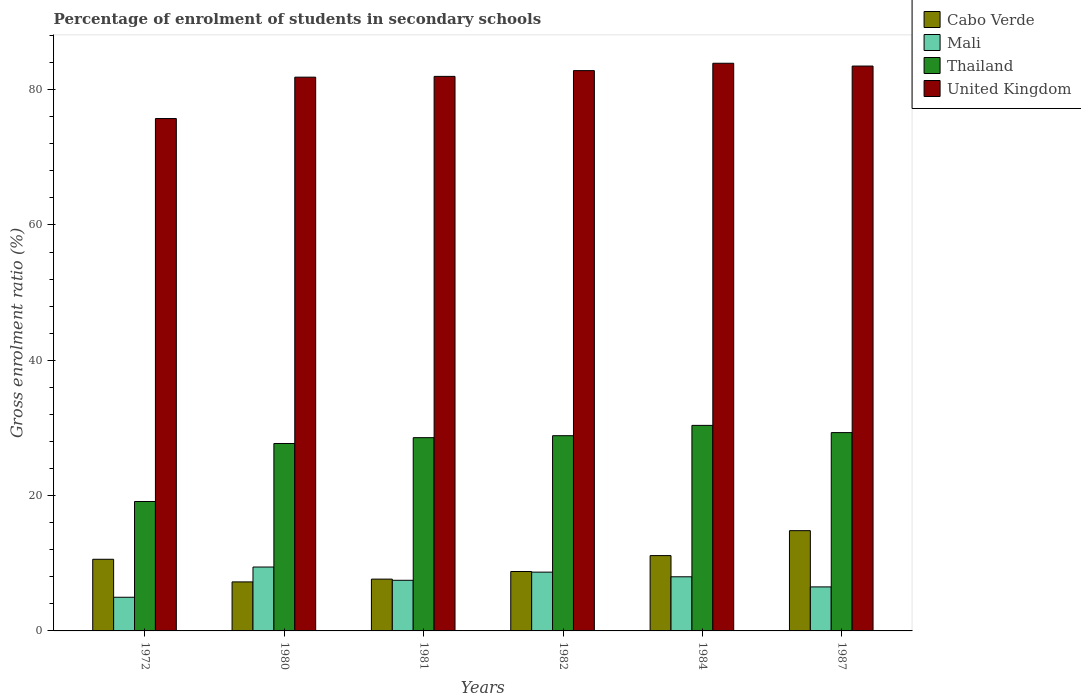Are the number of bars on each tick of the X-axis equal?
Provide a succinct answer. Yes. How many bars are there on the 3rd tick from the left?
Provide a short and direct response. 4. In how many cases, is the number of bars for a given year not equal to the number of legend labels?
Make the answer very short. 0. What is the percentage of students enrolled in secondary schools in Cabo Verde in 1987?
Ensure brevity in your answer.  14.82. Across all years, what is the maximum percentage of students enrolled in secondary schools in Thailand?
Ensure brevity in your answer.  30.38. Across all years, what is the minimum percentage of students enrolled in secondary schools in United Kingdom?
Your response must be concise. 75.72. In which year was the percentage of students enrolled in secondary schools in Cabo Verde maximum?
Ensure brevity in your answer.  1987. In which year was the percentage of students enrolled in secondary schools in Thailand minimum?
Make the answer very short. 1972. What is the total percentage of students enrolled in secondary schools in United Kingdom in the graph?
Your response must be concise. 489.71. What is the difference between the percentage of students enrolled in secondary schools in Mali in 1980 and that in 1981?
Ensure brevity in your answer.  1.96. What is the difference between the percentage of students enrolled in secondary schools in Thailand in 1987 and the percentage of students enrolled in secondary schools in Cabo Verde in 1980?
Provide a succinct answer. 22.07. What is the average percentage of students enrolled in secondary schools in Mali per year?
Give a very brief answer. 7.52. In the year 1972, what is the difference between the percentage of students enrolled in secondary schools in Cabo Verde and percentage of students enrolled in secondary schools in Thailand?
Provide a short and direct response. -8.54. In how many years, is the percentage of students enrolled in secondary schools in Thailand greater than 44 %?
Provide a short and direct response. 0. What is the ratio of the percentage of students enrolled in secondary schools in Thailand in 1980 to that in 1984?
Keep it short and to the point. 0.91. Is the difference between the percentage of students enrolled in secondary schools in Cabo Verde in 1984 and 1987 greater than the difference between the percentage of students enrolled in secondary schools in Thailand in 1984 and 1987?
Provide a short and direct response. No. What is the difference between the highest and the second highest percentage of students enrolled in secondary schools in Cabo Verde?
Offer a very short reply. 3.68. What is the difference between the highest and the lowest percentage of students enrolled in secondary schools in Thailand?
Give a very brief answer. 11.25. Is it the case that in every year, the sum of the percentage of students enrolled in secondary schools in Thailand and percentage of students enrolled in secondary schools in United Kingdom is greater than the sum of percentage of students enrolled in secondary schools in Cabo Verde and percentage of students enrolled in secondary schools in Mali?
Offer a terse response. Yes. What does the 3rd bar from the left in 1984 represents?
Offer a terse response. Thailand. What does the 4th bar from the right in 1982 represents?
Keep it short and to the point. Cabo Verde. What is the difference between two consecutive major ticks on the Y-axis?
Keep it short and to the point. 20. Does the graph contain any zero values?
Keep it short and to the point. No. How many legend labels are there?
Ensure brevity in your answer.  4. What is the title of the graph?
Make the answer very short. Percentage of enrolment of students in secondary schools. What is the label or title of the Y-axis?
Offer a terse response. Gross enrolment ratio (%). What is the Gross enrolment ratio (%) in Cabo Verde in 1972?
Ensure brevity in your answer.  10.59. What is the Gross enrolment ratio (%) in Mali in 1972?
Your response must be concise. 4.97. What is the Gross enrolment ratio (%) in Thailand in 1972?
Your response must be concise. 19.13. What is the Gross enrolment ratio (%) of United Kingdom in 1972?
Make the answer very short. 75.72. What is the Gross enrolment ratio (%) of Cabo Verde in 1980?
Your response must be concise. 7.24. What is the Gross enrolment ratio (%) of Mali in 1980?
Provide a short and direct response. 9.44. What is the Gross enrolment ratio (%) of Thailand in 1980?
Offer a terse response. 27.7. What is the Gross enrolment ratio (%) in United Kingdom in 1980?
Your answer should be very brief. 81.84. What is the Gross enrolment ratio (%) in Cabo Verde in 1981?
Make the answer very short. 7.66. What is the Gross enrolment ratio (%) of Mali in 1981?
Provide a short and direct response. 7.48. What is the Gross enrolment ratio (%) in Thailand in 1981?
Make the answer very short. 28.56. What is the Gross enrolment ratio (%) in United Kingdom in 1981?
Your answer should be very brief. 81.96. What is the Gross enrolment ratio (%) of Cabo Verde in 1982?
Your response must be concise. 8.78. What is the Gross enrolment ratio (%) of Mali in 1982?
Offer a terse response. 8.69. What is the Gross enrolment ratio (%) of Thailand in 1982?
Provide a succinct answer. 28.85. What is the Gross enrolment ratio (%) in United Kingdom in 1982?
Ensure brevity in your answer.  82.81. What is the Gross enrolment ratio (%) in Cabo Verde in 1984?
Give a very brief answer. 11.13. What is the Gross enrolment ratio (%) of Mali in 1984?
Your answer should be compact. 8. What is the Gross enrolment ratio (%) of Thailand in 1984?
Provide a succinct answer. 30.38. What is the Gross enrolment ratio (%) of United Kingdom in 1984?
Your answer should be very brief. 83.9. What is the Gross enrolment ratio (%) in Cabo Verde in 1987?
Your response must be concise. 14.82. What is the Gross enrolment ratio (%) of Mali in 1987?
Ensure brevity in your answer.  6.51. What is the Gross enrolment ratio (%) in Thailand in 1987?
Make the answer very short. 29.31. What is the Gross enrolment ratio (%) of United Kingdom in 1987?
Provide a succinct answer. 83.48. Across all years, what is the maximum Gross enrolment ratio (%) in Cabo Verde?
Your answer should be compact. 14.82. Across all years, what is the maximum Gross enrolment ratio (%) of Mali?
Offer a terse response. 9.44. Across all years, what is the maximum Gross enrolment ratio (%) in Thailand?
Keep it short and to the point. 30.38. Across all years, what is the maximum Gross enrolment ratio (%) in United Kingdom?
Ensure brevity in your answer.  83.9. Across all years, what is the minimum Gross enrolment ratio (%) of Cabo Verde?
Your answer should be compact. 7.24. Across all years, what is the minimum Gross enrolment ratio (%) in Mali?
Your answer should be very brief. 4.97. Across all years, what is the minimum Gross enrolment ratio (%) in Thailand?
Your answer should be compact. 19.13. Across all years, what is the minimum Gross enrolment ratio (%) of United Kingdom?
Offer a very short reply. 75.72. What is the total Gross enrolment ratio (%) in Cabo Verde in the graph?
Your answer should be very brief. 60.22. What is the total Gross enrolment ratio (%) in Mali in the graph?
Your answer should be compact. 45.1. What is the total Gross enrolment ratio (%) of Thailand in the graph?
Provide a short and direct response. 163.93. What is the total Gross enrolment ratio (%) of United Kingdom in the graph?
Offer a very short reply. 489.71. What is the difference between the Gross enrolment ratio (%) in Cabo Verde in 1972 and that in 1980?
Provide a short and direct response. 3.34. What is the difference between the Gross enrolment ratio (%) in Mali in 1972 and that in 1980?
Provide a short and direct response. -4.47. What is the difference between the Gross enrolment ratio (%) in Thailand in 1972 and that in 1980?
Your answer should be very brief. -8.57. What is the difference between the Gross enrolment ratio (%) of United Kingdom in 1972 and that in 1980?
Your answer should be compact. -6.12. What is the difference between the Gross enrolment ratio (%) in Cabo Verde in 1972 and that in 1981?
Provide a short and direct response. 2.93. What is the difference between the Gross enrolment ratio (%) in Mali in 1972 and that in 1981?
Offer a very short reply. -2.51. What is the difference between the Gross enrolment ratio (%) in Thailand in 1972 and that in 1981?
Make the answer very short. -9.43. What is the difference between the Gross enrolment ratio (%) in United Kingdom in 1972 and that in 1981?
Provide a succinct answer. -6.23. What is the difference between the Gross enrolment ratio (%) of Cabo Verde in 1972 and that in 1982?
Your answer should be compact. 1.81. What is the difference between the Gross enrolment ratio (%) in Mali in 1972 and that in 1982?
Your response must be concise. -3.71. What is the difference between the Gross enrolment ratio (%) in Thailand in 1972 and that in 1982?
Provide a short and direct response. -9.72. What is the difference between the Gross enrolment ratio (%) of United Kingdom in 1972 and that in 1982?
Your answer should be very brief. -7.08. What is the difference between the Gross enrolment ratio (%) in Cabo Verde in 1972 and that in 1984?
Ensure brevity in your answer.  -0.54. What is the difference between the Gross enrolment ratio (%) of Mali in 1972 and that in 1984?
Provide a succinct answer. -3.03. What is the difference between the Gross enrolment ratio (%) of Thailand in 1972 and that in 1984?
Offer a terse response. -11.25. What is the difference between the Gross enrolment ratio (%) of United Kingdom in 1972 and that in 1984?
Keep it short and to the point. -8.17. What is the difference between the Gross enrolment ratio (%) of Cabo Verde in 1972 and that in 1987?
Make the answer very short. -4.23. What is the difference between the Gross enrolment ratio (%) of Mali in 1972 and that in 1987?
Offer a terse response. -1.53. What is the difference between the Gross enrolment ratio (%) of Thailand in 1972 and that in 1987?
Offer a very short reply. -10.18. What is the difference between the Gross enrolment ratio (%) of United Kingdom in 1972 and that in 1987?
Make the answer very short. -7.76. What is the difference between the Gross enrolment ratio (%) in Cabo Verde in 1980 and that in 1981?
Your answer should be compact. -0.41. What is the difference between the Gross enrolment ratio (%) in Mali in 1980 and that in 1981?
Offer a terse response. 1.96. What is the difference between the Gross enrolment ratio (%) of Thailand in 1980 and that in 1981?
Give a very brief answer. -0.86. What is the difference between the Gross enrolment ratio (%) in United Kingdom in 1980 and that in 1981?
Give a very brief answer. -0.11. What is the difference between the Gross enrolment ratio (%) in Cabo Verde in 1980 and that in 1982?
Your response must be concise. -1.54. What is the difference between the Gross enrolment ratio (%) in Mali in 1980 and that in 1982?
Keep it short and to the point. 0.75. What is the difference between the Gross enrolment ratio (%) in Thailand in 1980 and that in 1982?
Ensure brevity in your answer.  -1.15. What is the difference between the Gross enrolment ratio (%) of United Kingdom in 1980 and that in 1982?
Ensure brevity in your answer.  -0.97. What is the difference between the Gross enrolment ratio (%) of Cabo Verde in 1980 and that in 1984?
Ensure brevity in your answer.  -3.89. What is the difference between the Gross enrolment ratio (%) of Mali in 1980 and that in 1984?
Offer a terse response. 1.44. What is the difference between the Gross enrolment ratio (%) of Thailand in 1980 and that in 1984?
Provide a short and direct response. -2.68. What is the difference between the Gross enrolment ratio (%) of United Kingdom in 1980 and that in 1984?
Offer a terse response. -2.05. What is the difference between the Gross enrolment ratio (%) of Cabo Verde in 1980 and that in 1987?
Your answer should be compact. -7.57. What is the difference between the Gross enrolment ratio (%) of Mali in 1980 and that in 1987?
Provide a succinct answer. 2.94. What is the difference between the Gross enrolment ratio (%) in Thailand in 1980 and that in 1987?
Ensure brevity in your answer.  -1.61. What is the difference between the Gross enrolment ratio (%) of United Kingdom in 1980 and that in 1987?
Keep it short and to the point. -1.64. What is the difference between the Gross enrolment ratio (%) of Cabo Verde in 1981 and that in 1982?
Give a very brief answer. -1.13. What is the difference between the Gross enrolment ratio (%) of Mali in 1981 and that in 1982?
Give a very brief answer. -1.21. What is the difference between the Gross enrolment ratio (%) in Thailand in 1981 and that in 1982?
Offer a very short reply. -0.29. What is the difference between the Gross enrolment ratio (%) of United Kingdom in 1981 and that in 1982?
Make the answer very short. -0.85. What is the difference between the Gross enrolment ratio (%) in Cabo Verde in 1981 and that in 1984?
Your response must be concise. -3.48. What is the difference between the Gross enrolment ratio (%) of Mali in 1981 and that in 1984?
Keep it short and to the point. -0.52. What is the difference between the Gross enrolment ratio (%) in Thailand in 1981 and that in 1984?
Provide a short and direct response. -1.82. What is the difference between the Gross enrolment ratio (%) in United Kingdom in 1981 and that in 1984?
Offer a very short reply. -1.94. What is the difference between the Gross enrolment ratio (%) in Cabo Verde in 1981 and that in 1987?
Make the answer very short. -7.16. What is the difference between the Gross enrolment ratio (%) in Mali in 1981 and that in 1987?
Offer a very short reply. 0.98. What is the difference between the Gross enrolment ratio (%) in Thailand in 1981 and that in 1987?
Offer a very short reply. -0.75. What is the difference between the Gross enrolment ratio (%) in United Kingdom in 1981 and that in 1987?
Your response must be concise. -1.53. What is the difference between the Gross enrolment ratio (%) in Cabo Verde in 1982 and that in 1984?
Keep it short and to the point. -2.35. What is the difference between the Gross enrolment ratio (%) in Mali in 1982 and that in 1984?
Give a very brief answer. 0.69. What is the difference between the Gross enrolment ratio (%) of Thailand in 1982 and that in 1984?
Ensure brevity in your answer.  -1.52. What is the difference between the Gross enrolment ratio (%) in United Kingdom in 1982 and that in 1984?
Your answer should be very brief. -1.09. What is the difference between the Gross enrolment ratio (%) in Cabo Verde in 1982 and that in 1987?
Ensure brevity in your answer.  -6.04. What is the difference between the Gross enrolment ratio (%) of Mali in 1982 and that in 1987?
Your answer should be compact. 2.18. What is the difference between the Gross enrolment ratio (%) of Thailand in 1982 and that in 1987?
Make the answer very short. -0.46. What is the difference between the Gross enrolment ratio (%) in United Kingdom in 1982 and that in 1987?
Give a very brief answer. -0.68. What is the difference between the Gross enrolment ratio (%) in Cabo Verde in 1984 and that in 1987?
Provide a short and direct response. -3.68. What is the difference between the Gross enrolment ratio (%) of Mali in 1984 and that in 1987?
Offer a very short reply. 1.5. What is the difference between the Gross enrolment ratio (%) of Thailand in 1984 and that in 1987?
Keep it short and to the point. 1.07. What is the difference between the Gross enrolment ratio (%) of United Kingdom in 1984 and that in 1987?
Your answer should be very brief. 0.41. What is the difference between the Gross enrolment ratio (%) in Cabo Verde in 1972 and the Gross enrolment ratio (%) in Mali in 1980?
Ensure brevity in your answer.  1.15. What is the difference between the Gross enrolment ratio (%) of Cabo Verde in 1972 and the Gross enrolment ratio (%) of Thailand in 1980?
Ensure brevity in your answer.  -17.11. What is the difference between the Gross enrolment ratio (%) in Cabo Verde in 1972 and the Gross enrolment ratio (%) in United Kingdom in 1980?
Provide a succinct answer. -71.25. What is the difference between the Gross enrolment ratio (%) of Mali in 1972 and the Gross enrolment ratio (%) of Thailand in 1980?
Offer a terse response. -22.72. What is the difference between the Gross enrolment ratio (%) in Mali in 1972 and the Gross enrolment ratio (%) in United Kingdom in 1980?
Make the answer very short. -76.87. What is the difference between the Gross enrolment ratio (%) of Thailand in 1972 and the Gross enrolment ratio (%) of United Kingdom in 1980?
Give a very brief answer. -62.71. What is the difference between the Gross enrolment ratio (%) of Cabo Verde in 1972 and the Gross enrolment ratio (%) of Mali in 1981?
Provide a short and direct response. 3.11. What is the difference between the Gross enrolment ratio (%) of Cabo Verde in 1972 and the Gross enrolment ratio (%) of Thailand in 1981?
Offer a very short reply. -17.97. What is the difference between the Gross enrolment ratio (%) in Cabo Verde in 1972 and the Gross enrolment ratio (%) in United Kingdom in 1981?
Provide a succinct answer. -71.37. What is the difference between the Gross enrolment ratio (%) of Mali in 1972 and the Gross enrolment ratio (%) of Thailand in 1981?
Your response must be concise. -23.59. What is the difference between the Gross enrolment ratio (%) of Mali in 1972 and the Gross enrolment ratio (%) of United Kingdom in 1981?
Ensure brevity in your answer.  -76.98. What is the difference between the Gross enrolment ratio (%) in Thailand in 1972 and the Gross enrolment ratio (%) in United Kingdom in 1981?
Provide a succinct answer. -62.83. What is the difference between the Gross enrolment ratio (%) in Cabo Verde in 1972 and the Gross enrolment ratio (%) in Mali in 1982?
Offer a very short reply. 1.9. What is the difference between the Gross enrolment ratio (%) in Cabo Verde in 1972 and the Gross enrolment ratio (%) in Thailand in 1982?
Your response must be concise. -18.26. What is the difference between the Gross enrolment ratio (%) of Cabo Verde in 1972 and the Gross enrolment ratio (%) of United Kingdom in 1982?
Give a very brief answer. -72.22. What is the difference between the Gross enrolment ratio (%) in Mali in 1972 and the Gross enrolment ratio (%) in Thailand in 1982?
Your response must be concise. -23.88. What is the difference between the Gross enrolment ratio (%) of Mali in 1972 and the Gross enrolment ratio (%) of United Kingdom in 1982?
Offer a very short reply. -77.83. What is the difference between the Gross enrolment ratio (%) of Thailand in 1972 and the Gross enrolment ratio (%) of United Kingdom in 1982?
Your answer should be compact. -63.68. What is the difference between the Gross enrolment ratio (%) in Cabo Verde in 1972 and the Gross enrolment ratio (%) in Mali in 1984?
Provide a succinct answer. 2.59. What is the difference between the Gross enrolment ratio (%) of Cabo Verde in 1972 and the Gross enrolment ratio (%) of Thailand in 1984?
Your answer should be compact. -19.79. What is the difference between the Gross enrolment ratio (%) in Cabo Verde in 1972 and the Gross enrolment ratio (%) in United Kingdom in 1984?
Offer a very short reply. -73.31. What is the difference between the Gross enrolment ratio (%) of Mali in 1972 and the Gross enrolment ratio (%) of Thailand in 1984?
Your response must be concise. -25.4. What is the difference between the Gross enrolment ratio (%) in Mali in 1972 and the Gross enrolment ratio (%) in United Kingdom in 1984?
Give a very brief answer. -78.92. What is the difference between the Gross enrolment ratio (%) of Thailand in 1972 and the Gross enrolment ratio (%) of United Kingdom in 1984?
Your answer should be very brief. -64.77. What is the difference between the Gross enrolment ratio (%) in Cabo Verde in 1972 and the Gross enrolment ratio (%) in Mali in 1987?
Offer a very short reply. 4.08. What is the difference between the Gross enrolment ratio (%) of Cabo Verde in 1972 and the Gross enrolment ratio (%) of Thailand in 1987?
Make the answer very short. -18.72. What is the difference between the Gross enrolment ratio (%) of Cabo Verde in 1972 and the Gross enrolment ratio (%) of United Kingdom in 1987?
Your answer should be very brief. -72.89. What is the difference between the Gross enrolment ratio (%) in Mali in 1972 and the Gross enrolment ratio (%) in Thailand in 1987?
Your answer should be compact. -24.34. What is the difference between the Gross enrolment ratio (%) of Mali in 1972 and the Gross enrolment ratio (%) of United Kingdom in 1987?
Your answer should be compact. -78.51. What is the difference between the Gross enrolment ratio (%) in Thailand in 1972 and the Gross enrolment ratio (%) in United Kingdom in 1987?
Your answer should be compact. -64.35. What is the difference between the Gross enrolment ratio (%) in Cabo Verde in 1980 and the Gross enrolment ratio (%) in Mali in 1981?
Keep it short and to the point. -0.24. What is the difference between the Gross enrolment ratio (%) of Cabo Verde in 1980 and the Gross enrolment ratio (%) of Thailand in 1981?
Provide a succinct answer. -21.32. What is the difference between the Gross enrolment ratio (%) of Cabo Verde in 1980 and the Gross enrolment ratio (%) of United Kingdom in 1981?
Offer a terse response. -74.71. What is the difference between the Gross enrolment ratio (%) of Mali in 1980 and the Gross enrolment ratio (%) of Thailand in 1981?
Give a very brief answer. -19.12. What is the difference between the Gross enrolment ratio (%) of Mali in 1980 and the Gross enrolment ratio (%) of United Kingdom in 1981?
Your response must be concise. -72.51. What is the difference between the Gross enrolment ratio (%) of Thailand in 1980 and the Gross enrolment ratio (%) of United Kingdom in 1981?
Make the answer very short. -54.26. What is the difference between the Gross enrolment ratio (%) in Cabo Verde in 1980 and the Gross enrolment ratio (%) in Mali in 1982?
Your answer should be compact. -1.44. What is the difference between the Gross enrolment ratio (%) in Cabo Verde in 1980 and the Gross enrolment ratio (%) in Thailand in 1982?
Make the answer very short. -21.61. What is the difference between the Gross enrolment ratio (%) of Cabo Verde in 1980 and the Gross enrolment ratio (%) of United Kingdom in 1982?
Keep it short and to the point. -75.56. What is the difference between the Gross enrolment ratio (%) in Mali in 1980 and the Gross enrolment ratio (%) in Thailand in 1982?
Your response must be concise. -19.41. What is the difference between the Gross enrolment ratio (%) in Mali in 1980 and the Gross enrolment ratio (%) in United Kingdom in 1982?
Offer a terse response. -73.36. What is the difference between the Gross enrolment ratio (%) in Thailand in 1980 and the Gross enrolment ratio (%) in United Kingdom in 1982?
Your answer should be very brief. -55.11. What is the difference between the Gross enrolment ratio (%) of Cabo Verde in 1980 and the Gross enrolment ratio (%) of Mali in 1984?
Offer a very short reply. -0.76. What is the difference between the Gross enrolment ratio (%) of Cabo Verde in 1980 and the Gross enrolment ratio (%) of Thailand in 1984?
Offer a very short reply. -23.13. What is the difference between the Gross enrolment ratio (%) of Cabo Verde in 1980 and the Gross enrolment ratio (%) of United Kingdom in 1984?
Offer a very short reply. -76.65. What is the difference between the Gross enrolment ratio (%) in Mali in 1980 and the Gross enrolment ratio (%) in Thailand in 1984?
Ensure brevity in your answer.  -20.93. What is the difference between the Gross enrolment ratio (%) in Mali in 1980 and the Gross enrolment ratio (%) in United Kingdom in 1984?
Keep it short and to the point. -74.45. What is the difference between the Gross enrolment ratio (%) in Thailand in 1980 and the Gross enrolment ratio (%) in United Kingdom in 1984?
Ensure brevity in your answer.  -56.2. What is the difference between the Gross enrolment ratio (%) of Cabo Verde in 1980 and the Gross enrolment ratio (%) of Mali in 1987?
Your answer should be compact. 0.74. What is the difference between the Gross enrolment ratio (%) of Cabo Verde in 1980 and the Gross enrolment ratio (%) of Thailand in 1987?
Offer a terse response. -22.07. What is the difference between the Gross enrolment ratio (%) in Cabo Verde in 1980 and the Gross enrolment ratio (%) in United Kingdom in 1987?
Offer a terse response. -76.24. What is the difference between the Gross enrolment ratio (%) of Mali in 1980 and the Gross enrolment ratio (%) of Thailand in 1987?
Your answer should be compact. -19.87. What is the difference between the Gross enrolment ratio (%) of Mali in 1980 and the Gross enrolment ratio (%) of United Kingdom in 1987?
Make the answer very short. -74.04. What is the difference between the Gross enrolment ratio (%) of Thailand in 1980 and the Gross enrolment ratio (%) of United Kingdom in 1987?
Give a very brief answer. -55.78. What is the difference between the Gross enrolment ratio (%) of Cabo Verde in 1981 and the Gross enrolment ratio (%) of Mali in 1982?
Your answer should be compact. -1.03. What is the difference between the Gross enrolment ratio (%) in Cabo Verde in 1981 and the Gross enrolment ratio (%) in Thailand in 1982?
Make the answer very short. -21.2. What is the difference between the Gross enrolment ratio (%) of Cabo Verde in 1981 and the Gross enrolment ratio (%) of United Kingdom in 1982?
Your response must be concise. -75.15. What is the difference between the Gross enrolment ratio (%) in Mali in 1981 and the Gross enrolment ratio (%) in Thailand in 1982?
Your response must be concise. -21.37. What is the difference between the Gross enrolment ratio (%) of Mali in 1981 and the Gross enrolment ratio (%) of United Kingdom in 1982?
Provide a succinct answer. -75.32. What is the difference between the Gross enrolment ratio (%) of Thailand in 1981 and the Gross enrolment ratio (%) of United Kingdom in 1982?
Give a very brief answer. -54.25. What is the difference between the Gross enrolment ratio (%) in Cabo Verde in 1981 and the Gross enrolment ratio (%) in Mali in 1984?
Keep it short and to the point. -0.35. What is the difference between the Gross enrolment ratio (%) of Cabo Verde in 1981 and the Gross enrolment ratio (%) of Thailand in 1984?
Your answer should be compact. -22.72. What is the difference between the Gross enrolment ratio (%) in Cabo Verde in 1981 and the Gross enrolment ratio (%) in United Kingdom in 1984?
Offer a very short reply. -76.24. What is the difference between the Gross enrolment ratio (%) of Mali in 1981 and the Gross enrolment ratio (%) of Thailand in 1984?
Your response must be concise. -22.89. What is the difference between the Gross enrolment ratio (%) of Mali in 1981 and the Gross enrolment ratio (%) of United Kingdom in 1984?
Your response must be concise. -76.41. What is the difference between the Gross enrolment ratio (%) of Thailand in 1981 and the Gross enrolment ratio (%) of United Kingdom in 1984?
Your answer should be very brief. -55.33. What is the difference between the Gross enrolment ratio (%) in Cabo Verde in 1981 and the Gross enrolment ratio (%) in Mali in 1987?
Your answer should be compact. 1.15. What is the difference between the Gross enrolment ratio (%) of Cabo Verde in 1981 and the Gross enrolment ratio (%) of Thailand in 1987?
Your answer should be compact. -21.66. What is the difference between the Gross enrolment ratio (%) of Cabo Verde in 1981 and the Gross enrolment ratio (%) of United Kingdom in 1987?
Keep it short and to the point. -75.83. What is the difference between the Gross enrolment ratio (%) in Mali in 1981 and the Gross enrolment ratio (%) in Thailand in 1987?
Provide a short and direct response. -21.83. What is the difference between the Gross enrolment ratio (%) of Mali in 1981 and the Gross enrolment ratio (%) of United Kingdom in 1987?
Your response must be concise. -76. What is the difference between the Gross enrolment ratio (%) in Thailand in 1981 and the Gross enrolment ratio (%) in United Kingdom in 1987?
Your answer should be compact. -54.92. What is the difference between the Gross enrolment ratio (%) of Cabo Verde in 1982 and the Gross enrolment ratio (%) of Mali in 1984?
Provide a succinct answer. 0.78. What is the difference between the Gross enrolment ratio (%) of Cabo Verde in 1982 and the Gross enrolment ratio (%) of Thailand in 1984?
Give a very brief answer. -21.6. What is the difference between the Gross enrolment ratio (%) of Cabo Verde in 1982 and the Gross enrolment ratio (%) of United Kingdom in 1984?
Make the answer very short. -75.11. What is the difference between the Gross enrolment ratio (%) of Mali in 1982 and the Gross enrolment ratio (%) of Thailand in 1984?
Provide a short and direct response. -21.69. What is the difference between the Gross enrolment ratio (%) of Mali in 1982 and the Gross enrolment ratio (%) of United Kingdom in 1984?
Keep it short and to the point. -75.21. What is the difference between the Gross enrolment ratio (%) of Thailand in 1982 and the Gross enrolment ratio (%) of United Kingdom in 1984?
Your response must be concise. -55.04. What is the difference between the Gross enrolment ratio (%) of Cabo Verde in 1982 and the Gross enrolment ratio (%) of Mali in 1987?
Offer a terse response. 2.28. What is the difference between the Gross enrolment ratio (%) of Cabo Verde in 1982 and the Gross enrolment ratio (%) of Thailand in 1987?
Provide a short and direct response. -20.53. What is the difference between the Gross enrolment ratio (%) of Cabo Verde in 1982 and the Gross enrolment ratio (%) of United Kingdom in 1987?
Ensure brevity in your answer.  -74.7. What is the difference between the Gross enrolment ratio (%) in Mali in 1982 and the Gross enrolment ratio (%) in Thailand in 1987?
Provide a succinct answer. -20.62. What is the difference between the Gross enrolment ratio (%) of Mali in 1982 and the Gross enrolment ratio (%) of United Kingdom in 1987?
Your response must be concise. -74.79. What is the difference between the Gross enrolment ratio (%) of Thailand in 1982 and the Gross enrolment ratio (%) of United Kingdom in 1987?
Provide a short and direct response. -54.63. What is the difference between the Gross enrolment ratio (%) in Cabo Verde in 1984 and the Gross enrolment ratio (%) in Mali in 1987?
Your answer should be compact. 4.63. What is the difference between the Gross enrolment ratio (%) in Cabo Verde in 1984 and the Gross enrolment ratio (%) in Thailand in 1987?
Ensure brevity in your answer.  -18.18. What is the difference between the Gross enrolment ratio (%) of Cabo Verde in 1984 and the Gross enrolment ratio (%) of United Kingdom in 1987?
Provide a short and direct response. -72.35. What is the difference between the Gross enrolment ratio (%) in Mali in 1984 and the Gross enrolment ratio (%) in Thailand in 1987?
Offer a terse response. -21.31. What is the difference between the Gross enrolment ratio (%) of Mali in 1984 and the Gross enrolment ratio (%) of United Kingdom in 1987?
Make the answer very short. -75.48. What is the difference between the Gross enrolment ratio (%) of Thailand in 1984 and the Gross enrolment ratio (%) of United Kingdom in 1987?
Provide a short and direct response. -53.11. What is the average Gross enrolment ratio (%) in Cabo Verde per year?
Ensure brevity in your answer.  10.04. What is the average Gross enrolment ratio (%) of Mali per year?
Keep it short and to the point. 7.52. What is the average Gross enrolment ratio (%) of Thailand per year?
Your answer should be compact. 27.32. What is the average Gross enrolment ratio (%) in United Kingdom per year?
Your answer should be very brief. 81.62. In the year 1972, what is the difference between the Gross enrolment ratio (%) of Cabo Verde and Gross enrolment ratio (%) of Mali?
Provide a succinct answer. 5.61. In the year 1972, what is the difference between the Gross enrolment ratio (%) in Cabo Verde and Gross enrolment ratio (%) in Thailand?
Ensure brevity in your answer.  -8.54. In the year 1972, what is the difference between the Gross enrolment ratio (%) of Cabo Verde and Gross enrolment ratio (%) of United Kingdom?
Provide a short and direct response. -65.14. In the year 1972, what is the difference between the Gross enrolment ratio (%) of Mali and Gross enrolment ratio (%) of Thailand?
Ensure brevity in your answer.  -14.15. In the year 1972, what is the difference between the Gross enrolment ratio (%) of Mali and Gross enrolment ratio (%) of United Kingdom?
Offer a terse response. -70.75. In the year 1972, what is the difference between the Gross enrolment ratio (%) of Thailand and Gross enrolment ratio (%) of United Kingdom?
Give a very brief answer. -56.6. In the year 1980, what is the difference between the Gross enrolment ratio (%) of Cabo Verde and Gross enrolment ratio (%) of Mali?
Offer a very short reply. -2.2. In the year 1980, what is the difference between the Gross enrolment ratio (%) of Cabo Verde and Gross enrolment ratio (%) of Thailand?
Your answer should be very brief. -20.46. In the year 1980, what is the difference between the Gross enrolment ratio (%) in Cabo Verde and Gross enrolment ratio (%) in United Kingdom?
Ensure brevity in your answer.  -74.6. In the year 1980, what is the difference between the Gross enrolment ratio (%) of Mali and Gross enrolment ratio (%) of Thailand?
Offer a very short reply. -18.26. In the year 1980, what is the difference between the Gross enrolment ratio (%) in Mali and Gross enrolment ratio (%) in United Kingdom?
Give a very brief answer. -72.4. In the year 1980, what is the difference between the Gross enrolment ratio (%) in Thailand and Gross enrolment ratio (%) in United Kingdom?
Keep it short and to the point. -54.14. In the year 1981, what is the difference between the Gross enrolment ratio (%) of Cabo Verde and Gross enrolment ratio (%) of Mali?
Offer a terse response. 0.17. In the year 1981, what is the difference between the Gross enrolment ratio (%) of Cabo Verde and Gross enrolment ratio (%) of Thailand?
Give a very brief answer. -20.91. In the year 1981, what is the difference between the Gross enrolment ratio (%) of Cabo Verde and Gross enrolment ratio (%) of United Kingdom?
Your answer should be compact. -74.3. In the year 1981, what is the difference between the Gross enrolment ratio (%) in Mali and Gross enrolment ratio (%) in Thailand?
Ensure brevity in your answer.  -21.08. In the year 1981, what is the difference between the Gross enrolment ratio (%) in Mali and Gross enrolment ratio (%) in United Kingdom?
Give a very brief answer. -74.47. In the year 1981, what is the difference between the Gross enrolment ratio (%) in Thailand and Gross enrolment ratio (%) in United Kingdom?
Offer a terse response. -53.39. In the year 1982, what is the difference between the Gross enrolment ratio (%) of Cabo Verde and Gross enrolment ratio (%) of Mali?
Keep it short and to the point. 0.09. In the year 1982, what is the difference between the Gross enrolment ratio (%) in Cabo Verde and Gross enrolment ratio (%) in Thailand?
Keep it short and to the point. -20.07. In the year 1982, what is the difference between the Gross enrolment ratio (%) of Cabo Verde and Gross enrolment ratio (%) of United Kingdom?
Offer a terse response. -74.03. In the year 1982, what is the difference between the Gross enrolment ratio (%) of Mali and Gross enrolment ratio (%) of Thailand?
Keep it short and to the point. -20.16. In the year 1982, what is the difference between the Gross enrolment ratio (%) in Mali and Gross enrolment ratio (%) in United Kingdom?
Your answer should be very brief. -74.12. In the year 1982, what is the difference between the Gross enrolment ratio (%) of Thailand and Gross enrolment ratio (%) of United Kingdom?
Keep it short and to the point. -53.95. In the year 1984, what is the difference between the Gross enrolment ratio (%) of Cabo Verde and Gross enrolment ratio (%) of Mali?
Give a very brief answer. 3.13. In the year 1984, what is the difference between the Gross enrolment ratio (%) in Cabo Verde and Gross enrolment ratio (%) in Thailand?
Ensure brevity in your answer.  -19.25. In the year 1984, what is the difference between the Gross enrolment ratio (%) of Cabo Verde and Gross enrolment ratio (%) of United Kingdom?
Provide a succinct answer. -72.76. In the year 1984, what is the difference between the Gross enrolment ratio (%) in Mali and Gross enrolment ratio (%) in Thailand?
Keep it short and to the point. -22.38. In the year 1984, what is the difference between the Gross enrolment ratio (%) of Mali and Gross enrolment ratio (%) of United Kingdom?
Provide a short and direct response. -75.89. In the year 1984, what is the difference between the Gross enrolment ratio (%) of Thailand and Gross enrolment ratio (%) of United Kingdom?
Your answer should be compact. -53.52. In the year 1987, what is the difference between the Gross enrolment ratio (%) in Cabo Verde and Gross enrolment ratio (%) in Mali?
Offer a terse response. 8.31. In the year 1987, what is the difference between the Gross enrolment ratio (%) in Cabo Verde and Gross enrolment ratio (%) in Thailand?
Provide a short and direct response. -14.49. In the year 1987, what is the difference between the Gross enrolment ratio (%) of Cabo Verde and Gross enrolment ratio (%) of United Kingdom?
Provide a short and direct response. -68.67. In the year 1987, what is the difference between the Gross enrolment ratio (%) of Mali and Gross enrolment ratio (%) of Thailand?
Keep it short and to the point. -22.8. In the year 1987, what is the difference between the Gross enrolment ratio (%) in Mali and Gross enrolment ratio (%) in United Kingdom?
Your response must be concise. -76.98. In the year 1987, what is the difference between the Gross enrolment ratio (%) in Thailand and Gross enrolment ratio (%) in United Kingdom?
Your response must be concise. -54.17. What is the ratio of the Gross enrolment ratio (%) of Cabo Verde in 1972 to that in 1980?
Your answer should be very brief. 1.46. What is the ratio of the Gross enrolment ratio (%) of Mali in 1972 to that in 1980?
Provide a succinct answer. 0.53. What is the ratio of the Gross enrolment ratio (%) in Thailand in 1972 to that in 1980?
Offer a very short reply. 0.69. What is the ratio of the Gross enrolment ratio (%) of United Kingdom in 1972 to that in 1980?
Offer a terse response. 0.93. What is the ratio of the Gross enrolment ratio (%) of Cabo Verde in 1972 to that in 1981?
Make the answer very short. 1.38. What is the ratio of the Gross enrolment ratio (%) in Mali in 1972 to that in 1981?
Your response must be concise. 0.66. What is the ratio of the Gross enrolment ratio (%) of Thailand in 1972 to that in 1981?
Offer a very short reply. 0.67. What is the ratio of the Gross enrolment ratio (%) of United Kingdom in 1972 to that in 1981?
Provide a short and direct response. 0.92. What is the ratio of the Gross enrolment ratio (%) of Cabo Verde in 1972 to that in 1982?
Your answer should be very brief. 1.21. What is the ratio of the Gross enrolment ratio (%) of Mali in 1972 to that in 1982?
Provide a succinct answer. 0.57. What is the ratio of the Gross enrolment ratio (%) of Thailand in 1972 to that in 1982?
Your response must be concise. 0.66. What is the ratio of the Gross enrolment ratio (%) in United Kingdom in 1972 to that in 1982?
Your answer should be compact. 0.91. What is the ratio of the Gross enrolment ratio (%) of Cabo Verde in 1972 to that in 1984?
Your answer should be very brief. 0.95. What is the ratio of the Gross enrolment ratio (%) in Mali in 1972 to that in 1984?
Your answer should be very brief. 0.62. What is the ratio of the Gross enrolment ratio (%) of Thailand in 1972 to that in 1984?
Provide a succinct answer. 0.63. What is the ratio of the Gross enrolment ratio (%) of United Kingdom in 1972 to that in 1984?
Your answer should be compact. 0.9. What is the ratio of the Gross enrolment ratio (%) of Cabo Verde in 1972 to that in 1987?
Provide a short and direct response. 0.71. What is the ratio of the Gross enrolment ratio (%) in Mali in 1972 to that in 1987?
Offer a very short reply. 0.76. What is the ratio of the Gross enrolment ratio (%) of Thailand in 1972 to that in 1987?
Ensure brevity in your answer.  0.65. What is the ratio of the Gross enrolment ratio (%) of United Kingdom in 1972 to that in 1987?
Your response must be concise. 0.91. What is the ratio of the Gross enrolment ratio (%) in Cabo Verde in 1980 to that in 1981?
Offer a terse response. 0.95. What is the ratio of the Gross enrolment ratio (%) in Mali in 1980 to that in 1981?
Offer a terse response. 1.26. What is the ratio of the Gross enrolment ratio (%) of Thailand in 1980 to that in 1981?
Keep it short and to the point. 0.97. What is the ratio of the Gross enrolment ratio (%) in Cabo Verde in 1980 to that in 1982?
Provide a succinct answer. 0.82. What is the ratio of the Gross enrolment ratio (%) in Mali in 1980 to that in 1982?
Provide a short and direct response. 1.09. What is the ratio of the Gross enrolment ratio (%) of Thailand in 1980 to that in 1982?
Offer a terse response. 0.96. What is the ratio of the Gross enrolment ratio (%) of United Kingdom in 1980 to that in 1982?
Your response must be concise. 0.99. What is the ratio of the Gross enrolment ratio (%) of Cabo Verde in 1980 to that in 1984?
Keep it short and to the point. 0.65. What is the ratio of the Gross enrolment ratio (%) in Mali in 1980 to that in 1984?
Provide a short and direct response. 1.18. What is the ratio of the Gross enrolment ratio (%) in Thailand in 1980 to that in 1984?
Keep it short and to the point. 0.91. What is the ratio of the Gross enrolment ratio (%) of United Kingdom in 1980 to that in 1984?
Your answer should be very brief. 0.98. What is the ratio of the Gross enrolment ratio (%) of Cabo Verde in 1980 to that in 1987?
Provide a short and direct response. 0.49. What is the ratio of the Gross enrolment ratio (%) of Mali in 1980 to that in 1987?
Your response must be concise. 1.45. What is the ratio of the Gross enrolment ratio (%) of Thailand in 1980 to that in 1987?
Make the answer very short. 0.94. What is the ratio of the Gross enrolment ratio (%) in United Kingdom in 1980 to that in 1987?
Give a very brief answer. 0.98. What is the ratio of the Gross enrolment ratio (%) in Cabo Verde in 1981 to that in 1982?
Your answer should be compact. 0.87. What is the ratio of the Gross enrolment ratio (%) in Mali in 1981 to that in 1982?
Your answer should be compact. 0.86. What is the ratio of the Gross enrolment ratio (%) of Cabo Verde in 1981 to that in 1984?
Offer a very short reply. 0.69. What is the ratio of the Gross enrolment ratio (%) of Mali in 1981 to that in 1984?
Your response must be concise. 0.94. What is the ratio of the Gross enrolment ratio (%) in Thailand in 1981 to that in 1984?
Provide a succinct answer. 0.94. What is the ratio of the Gross enrolment ratio (%) of United Kingdom in 1981 to that in 1984?
Provide a succinct answer. 0.98. What is the ratio of the Gross enrolment ratio (%) in Cabo Verde in 1981 to that in 1987?
Your response must be concise. 0.52. What is the ratio of the Gross enrolment ratio (%) in Mali in 1981 to that in 1987?
Offer a terse response. 1.15. What is the ratio of the Gross enrolment ratio (%) in Thailand in 1981 to that in 1987?
Offer a terse response. 0.97. What is the ratio of the Gross enrolment ratio (%) in United Kingdom in 1981 to that in 1987?
Give a very brief answer. 0.98. What is the ratio of the Gross enrolment ratio (%) of Cabo Verde in 1982 to that in 1984?
Offer a very short reply. 0.79. What is the ratio of the Gross enrolment ratio (%) of Mali in 1982 to that in 1984?
Provide a succinct answer. 1.09. What is the ratio of the Gross enrolment ratio (%) of Thailand in 1982 to that in 1984?
Make the answer very short. 0.95. What is the ratio of the Gross enrolment ratio (%) of United Kingdom in 1982 to that in 1984?
Keep it short and to the point. 0.99. What is the ratio of the Gross enrolment ratio (%) of Cabo Verde in 1982 to that in 1987?
Your answer should be very brief. 0.59. What is the ratio of the Gross enrolment ratio (%) of Mali in 1982 to that in 1987?
Provide a succinct answer. 1.34. What is the ratio of the Gross enrolment ratio (%) in Thailand in 1982 to that in 1987?
Provide a succinct answer. 0.98. What is the ratio of the Gross enrolment ratio (%) in United Kingdom in 1982 to that in 1987?
Ensure brevity in your answer.  0.99. What is the ratio of the Gross enrolment ratio (%) in Cabo Verde in 1984 to that in 1987?
Provide a short and direct response. 0.75. What is the ratio of the Gross enrolment ratio (%) in Mali in 1984 to that in 1987?
Provide a succinct answer. 1.23. What is the ratio of the Gross enrolment ratio (%) in Thailand in 1984 to that in 1987?
Your answer should be very brief. 1.04. What is the difference between the highest and the second highest Gross enrolment ratio (%) of Cabo Verde?
Provide a short and direct response. 3.68. What is the difference between the highest and the second highest Gross enrolment ratio (%) in Mali?
Provide a succinct answer. 0.75. What is the difference between the highest and the second highest Gross enrolment ratio (%) of Thailand?
Provide a succinct answer. 1.07. What is the difference between the highest and the second highest Gross enrolment ratio (%) of United Kingdom?
Provide a short and direct response. 0.41. What is the difference between the highest and the lowest Gross enrolment ratio (%) of Cabo Verde?
Your response must be concise. 7.57. What is the difference between the highest and the lowest Gross enrolment ratio (%) in Mali?
Offer a very short reply. 4.47. What is the difference between the highest and the lowest Gross enrolment ratio (%) in Thailand?
Give a very brief answer. 11.25. What is the difference between the highest and the lowest Gross enrolment ratio (%) of United Kingdom?
Provide a short and direct response. 8.17. 